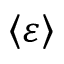Convert formula to latex. <formula><loc_0><loc_0><loc_500><loc_500>\left \langle \varepsilon \right \rangle</formula> 